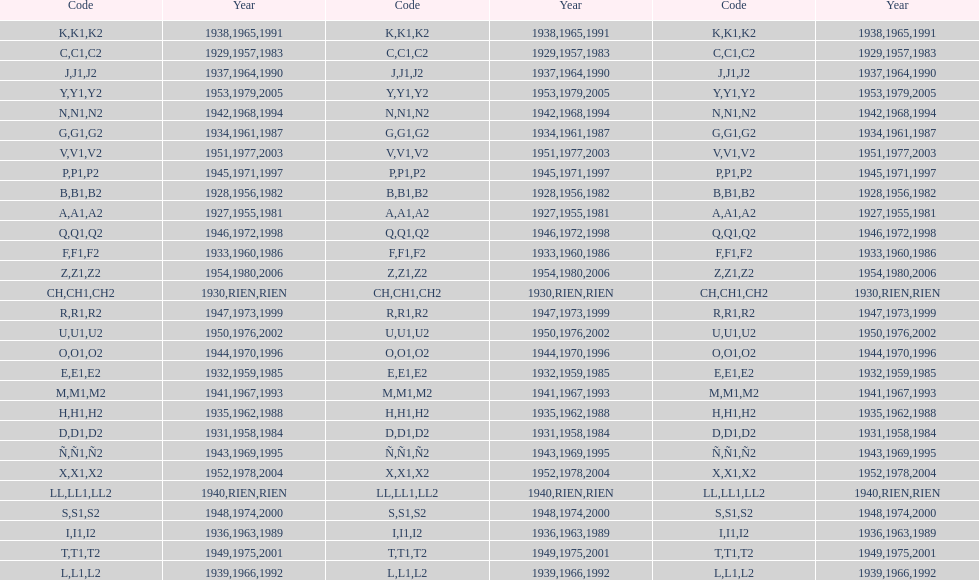What was the only year to use the code ch? 1930. 